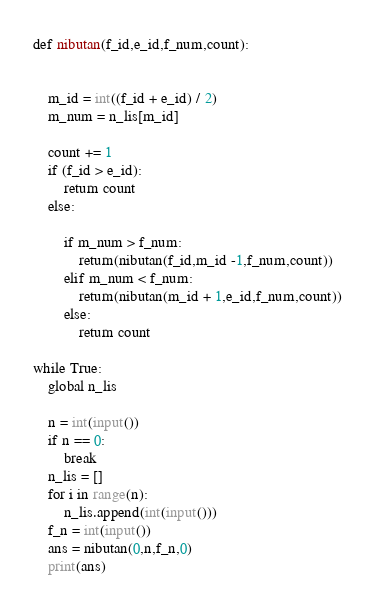Convert code to text. <code><loc_0><loc_0><loc_500><loc_500><_Python_>def nibutan(f_id,e_id,f_num,count):
    
    
    m_id = int((f_id + e_id) / 2)
    m_num = n_lis[m_id]

    count += 1
    if (f_id > e_id):
        return count
    else:

        if m_num > f_num:
            return(nibutan(f_id,m_id -1,f_num,count))
        elif m_num < f_num:
            return(nibutan(m_id + 1,e_id,f_num,count))
        else:
            return count
                
while True:
    global n_lis

    n = int(input())
    if n == 0:
        break
    n_lis = []
    for i in range(n):
        n_lis.append(int(input()))
    f_n = int(input())
    ans = nibutan(0,n,f_n,0)
    print(ans)</code> 